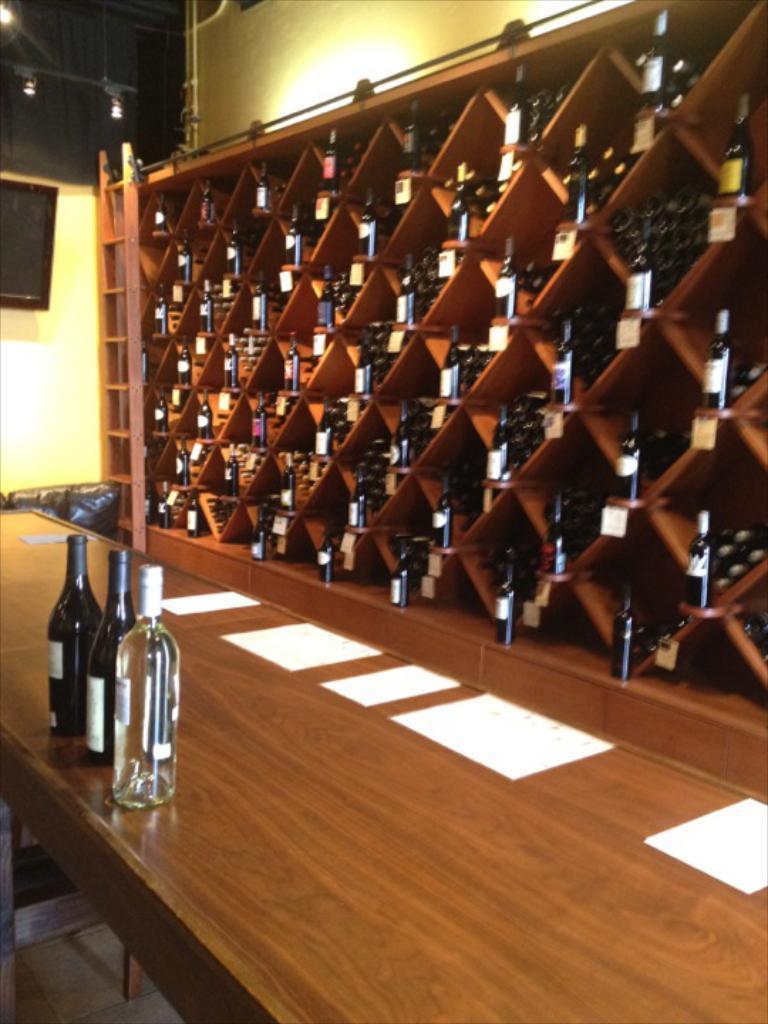In one or two sentences, can you explain what this image depicts? In the image there are three wine bottles on the table along with tissues, in the back there is rack with many wine bottles in it, this seems to be inside a bar, on the left side there is a tv on the wall. 